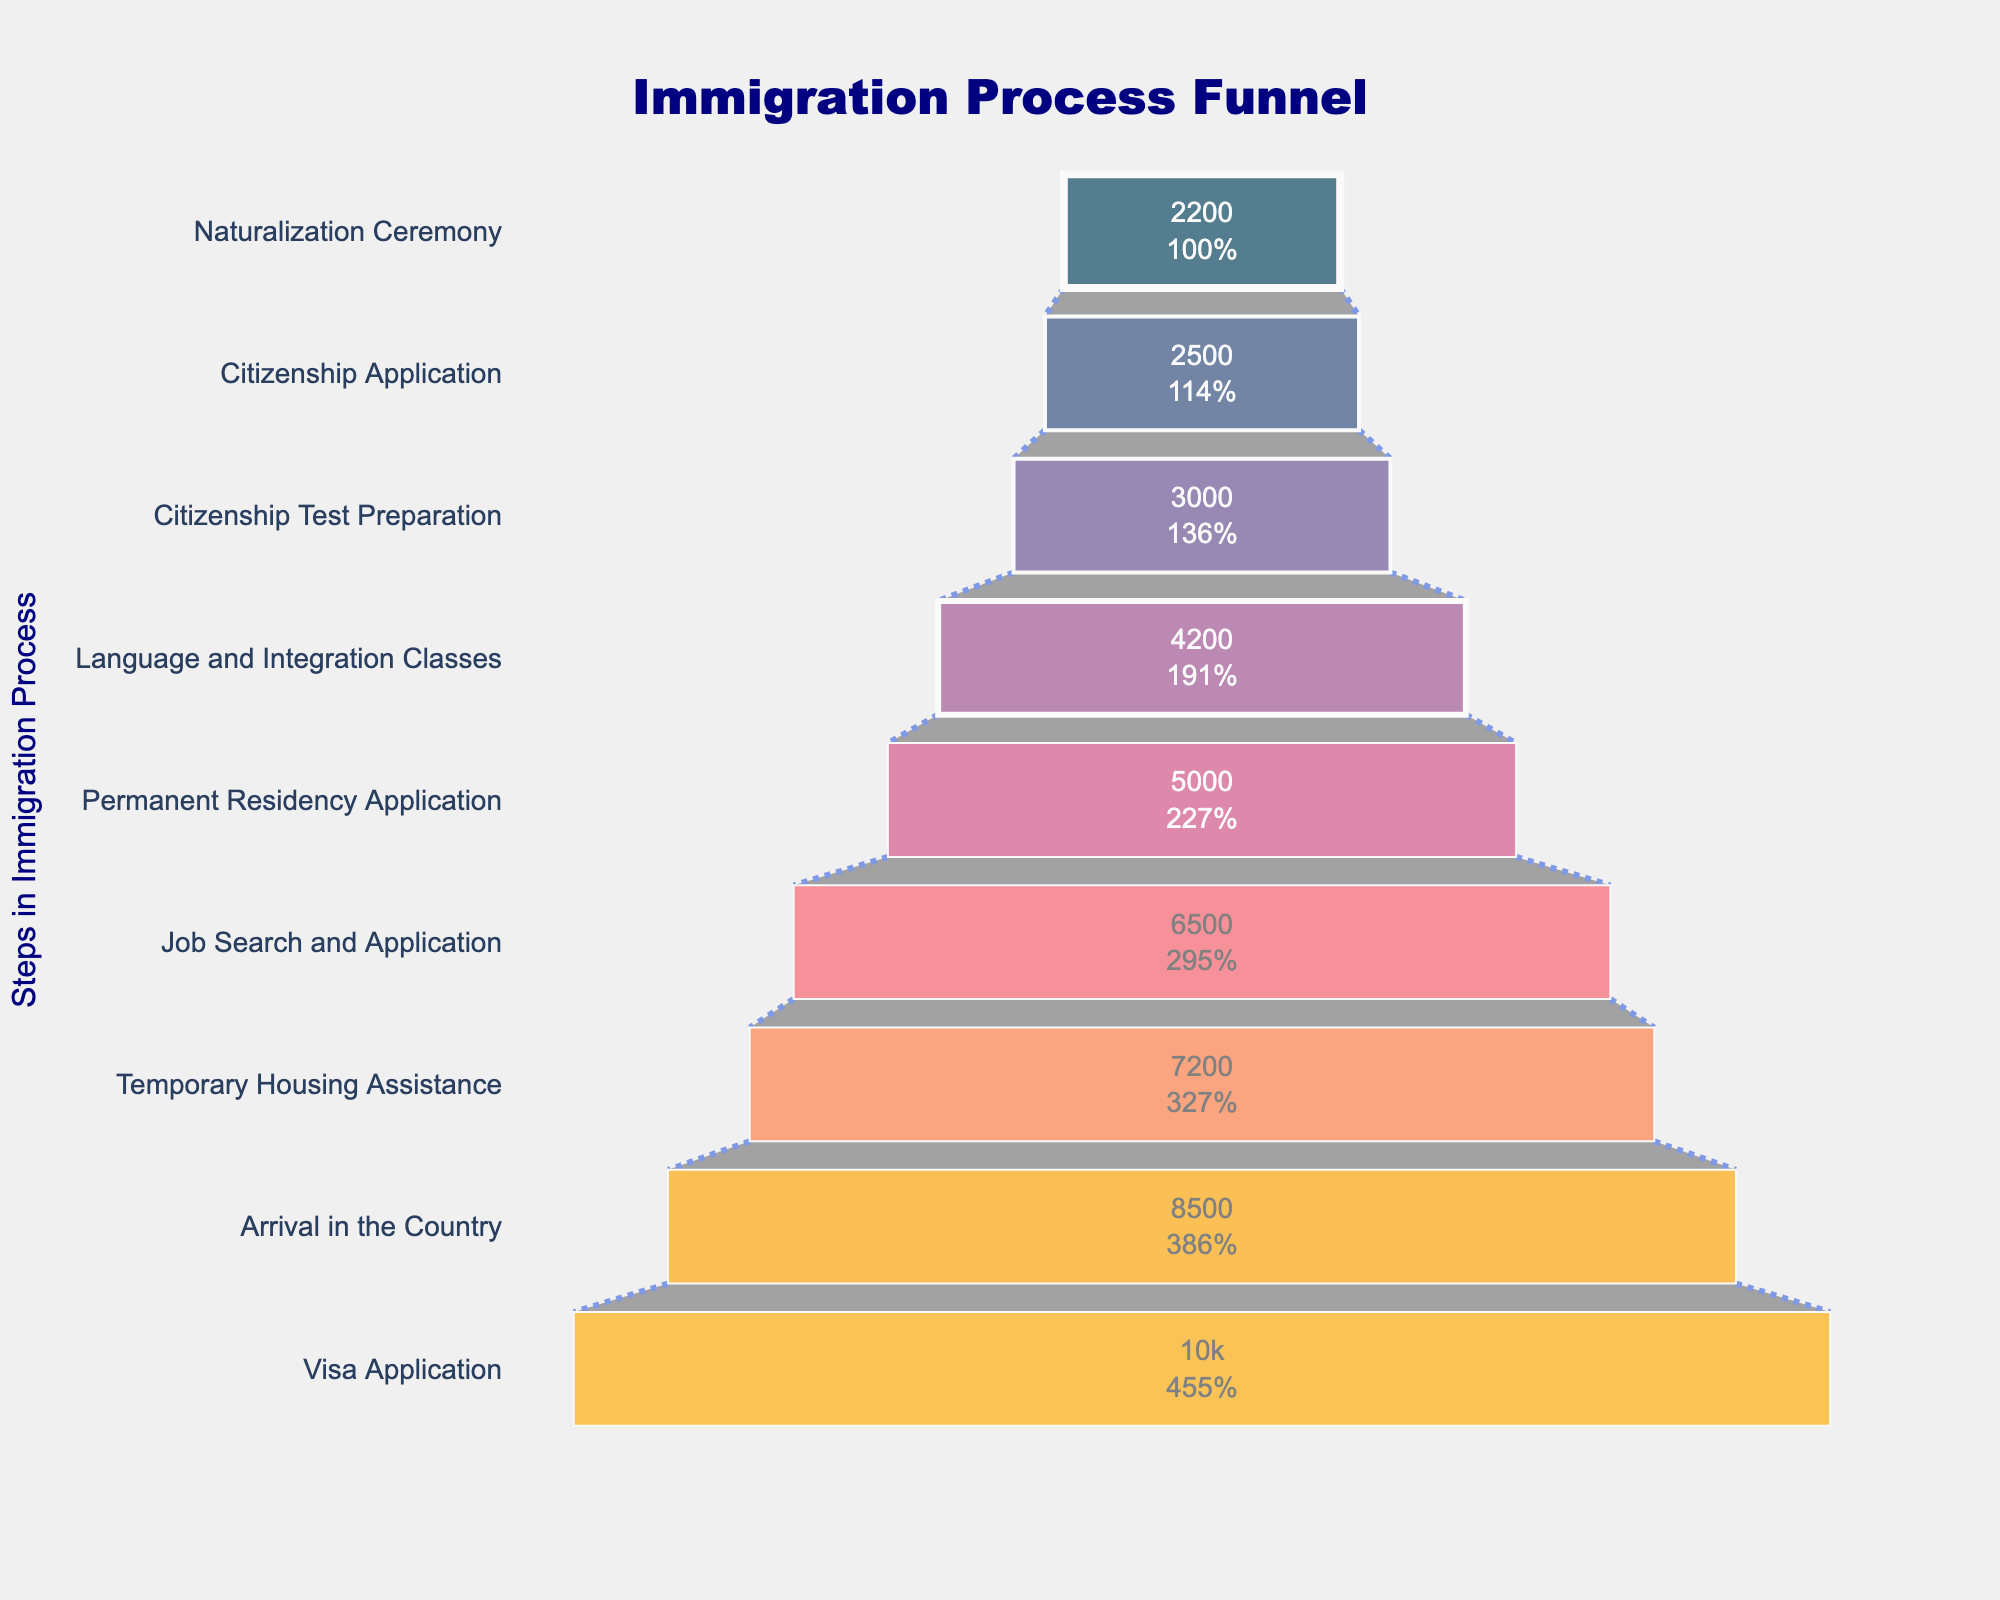What is the title of the funnel chart? The title of the chart is displayed prominently at the top.
Answer: Immigration Process Funnel Which step has the largest number of applicants? By looking at the top of the funnel, we see the step with the highest number of applicants.
Answer: Visa Application How many people reach the Naturalization Ceremony step? The bottom of the funnel represents the last step, which indicates the number of people at the Naturalization Ceremony step.
Answer: 2200 What is the percentage decrease from Visa Application to Arrival in the Country? The initial percentage decrease can be calculated as (10000 - 8500) / 10000 * 100 = 15%.
Answer: 15% How many steps are there in the immigration process according to the funnel chart? Count the number of different stages (bars) present in the funnel chart.
Answer: 9 What is the percentage of applicants who proceed from the Job Search and Application to the Permanent Residency Application? Calculate the percentage of applicants from the Job Search and Application step who proceed to the next stage. (5000 / 6500) * 100 = 76.92%.
Answer: 76.92% Compare the number of applicants in Temporary Housing Assistance to Citizenship Application. Which has more applicants? Compare the values for Temporary Housing Assistance (7200) and Citizenship Application (2500) by checking the respective bars.
Answer: Temporary Housing Assistance How many applicants participated in Language and Integration Classes? Identify and read the value associated with the Language and Integration Classes step in the funnel chart.
Answer: 4200 Which step shows the largest drop in the number of applicants and quantify that drop? Find the step with the most significant numerical decrease by comparing adjacent steps. The largest drop is from Language and Integration Classes (4200) to Citizenship Test Preparation (3000), a difference of 1200.
Answer: Language and Integration Classes to Citizenship Test Preparation, 1200 What is the total number of applicants from the Visa Application to the Citizenship Test Preparation steps? Add the number of applicants from these steps: 10000 + 8500 + 7200 + 6500 + 5000 + 4200 + 3000 = 44400.
Answer: 44400 